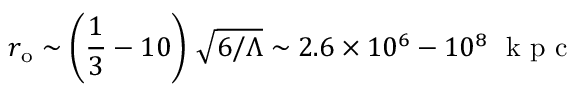Convert formula to latex. <formula><loc_0><loc_0><loc_500><loc_500>r _ { o } \sim \left ( \frac { 1 } { 3 } - 1 0 \right ) \, \sqrt { 6 / \Lambda } \sim 2 . 6 \times 1 0 ^ { 6 } - 1 0 ^ { 8 } k p c</formula> 